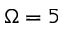Convert formula to latex. <formula><loc_0><loc_0><loc_500><loc_500>\Omega = 5</formula> 